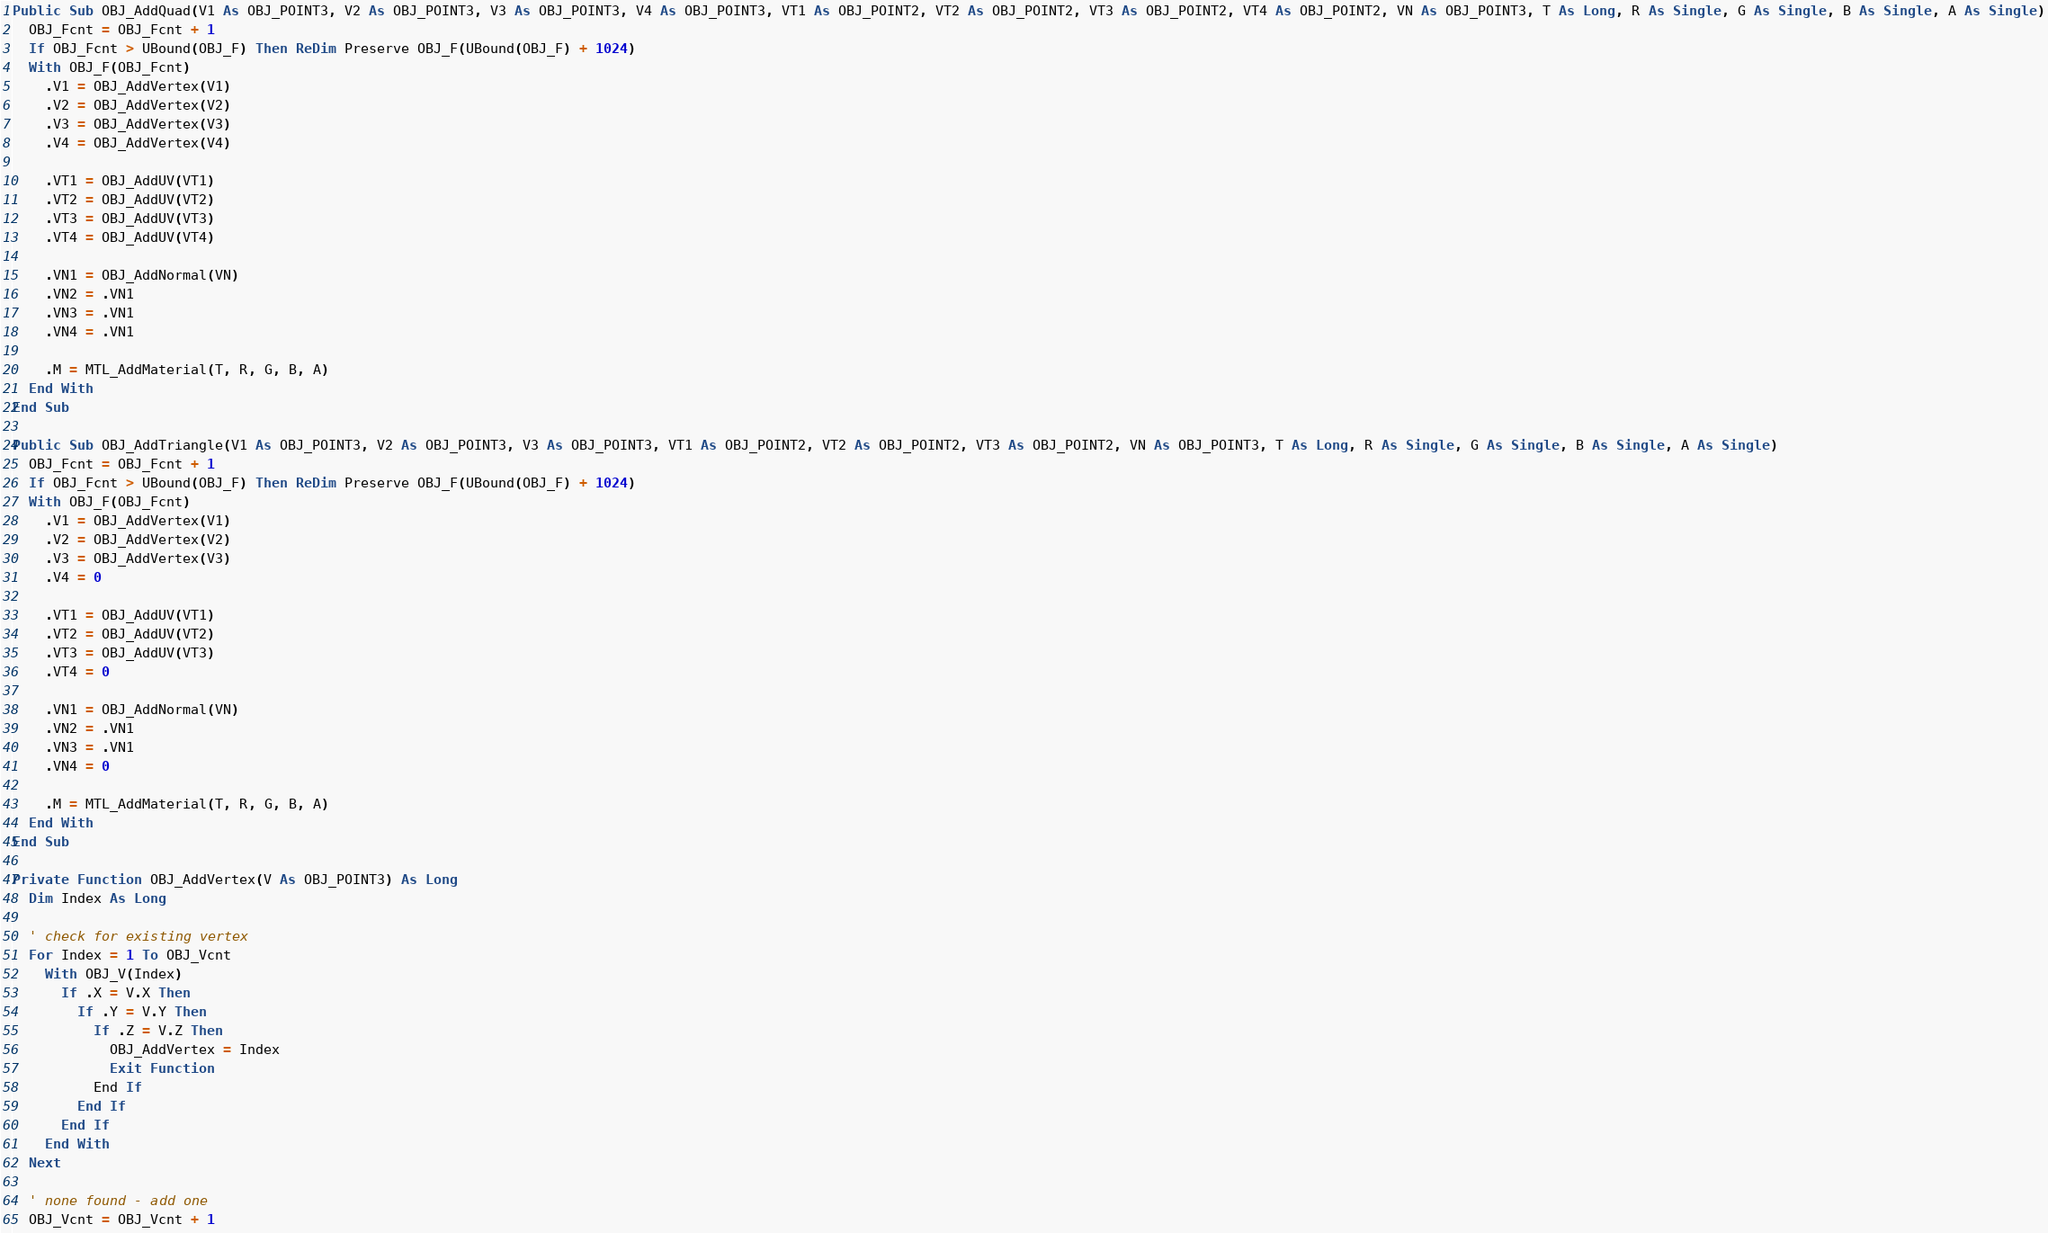<code> <loc_0><loc_0><loc_500><loc_500><_VisualBasic_>
Public Sub OBJ_AddQuad(V1 As OBJ_POINT3, V2 As OBJ_POINT3, V3 As OBJ_POINT3, V4 As OBJ_POINT3, VT1 As OBJ_POINT2, VT2 As OBJ_POINT2, VT3 As OBJ_POINT2, VT4 As OBJ_POINT2, VN As OBJ_POINT3, T As Long, R As Single, G As Single, B As Single, A As Single)
  OBJ_Fcnt = OBJ_Fcnt + 1
  If OBJ_Fcnt > UBound(OBJ_F) Then ReDim Preserve OBJ_F(UBound(OBJ_F) + 1024)
  With OBJ_F(OBJ_Fcnt)
    .V1 = OBJ_AddVertex(V1)
    .V2 = OBJ_AddVertex(V2)
    .V3 = OBJ_AddVertex(V3)
    .V4 = OBJ_AddVertex(V4)
    
    .VT1 = OBJ_AddUV(VT1)
    .VT2 = OBJ_AddUV(VT2)
    .VT3 = OBJ_AddUV(VT3)
    .VT4 = OBJ_AddUV(VT4)
    
    .VN1 = OBJ_AddNormal(VN)
    .VN2 = .VN1
    .VN3 = .VN1
    .VN4 = .VN1
  
    .M = MTL_AddMaterial(T, R, G, B, A)
  End With
End Sub

Public Sub OBJ_AddTriangle(V1 As OBJ_POINT3, V2 As OBJ_POINT3, V3 As OBJ_POINT3, VT1 As OBJ_POINT2, VT2 As OBJ_POINT2, VT3 As OBJ_POINT2, VN As OBJ_POINT3, T As Long, R As Single, G As Single, B As Single, A As Single)
  OBJ_Fcnt = OBJ_Fcnt + 1
  If OBJ_Fcnt > UBound(OBJ_F) Then ReDim Preserve OBJ_F(UBound(OBJ_F) + 1024)
  With OBJ_F(OBJ_Fcnt)
    .V1 = OBJ_AddVertex(V1)
    .V2 = OBJ_AddVertex(V2)
    .V3 = OBJ_AddVertex(V3)
    .V4 = 0
  
    .VT1 = OBJ_AddUV(VT1)
    .VT2 = OBJ_AddUV(VT2)
    .VT3 = OBJ_AddUV(VT3)
    .VT4 = 0
    
    .VN1 = OBJ_AddNormal(VN)
    .VN2 = .VN1
    .VN3 = .VN1
    .VN4 = 0
    
    .M = MTL_AddMaterial(T, R, G, B, A)
  End With
End Sub

Private Function OBJ_AddVertex(V As OBJ_POINT3) As Long
  Dim Index As Long
  
  ' check for existing vertex
  For Index = 1 To OBJ_Vcnt
    With OBJ_V(Index)
      If .X = V.X Then
        If .Y = V.Y Then
          If .Z = V.Z Then
            OBJ_AddVertex = Index
            Exit Function
          End If
        End If
      End If
    End With
  Next
  
  ' none found - add one
  OBJ_Vcnt = OBJ_Vcnt + 1</code> 